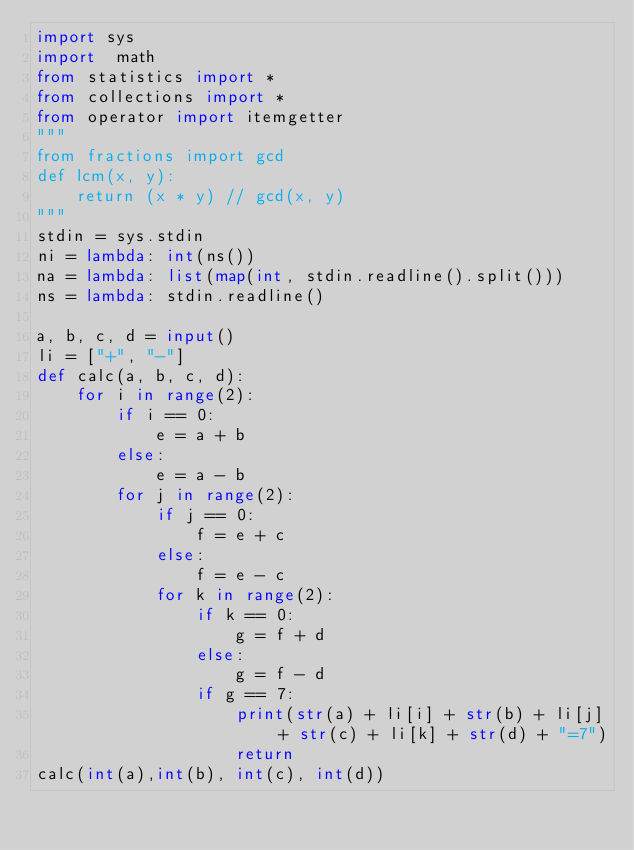Convert code to text. <code><loc_0><loc_0><loc_500><loc_500><_Python_>import sys
import  math
from statistics import *
from collections import *
from operator import itemgetter
"""
from fractions import gcd
def lcm(x, y):
    return (x * y) // gcd(x, y)
"""
stdin = sys.stdin
ni = lambda: int(ns())
na = lambda: list(map(int, stdin.readline().split()))
ns = lambda: stdin.readline()

a, b, c, d = input()
li = ["+", "-"]
def calc(a, b, c, d):
    for i in range(2):
        if i == 0:
            e = a + b
        else:
            e = a - b
        for j in range(2):
            if j == 0:
                f = e + c
            else:
                f = e - c
            for k in range(2):
                if k == 0:
                    g = f + d
                else:
                    g = f - d
                if g == 7:
                    print(str(a) + li[i] + str(b) + li[j] + str(c) + li[k] + str(d) + "=7")
                    return
calc(int(a),int(b), int(c), int(d))
</code> 